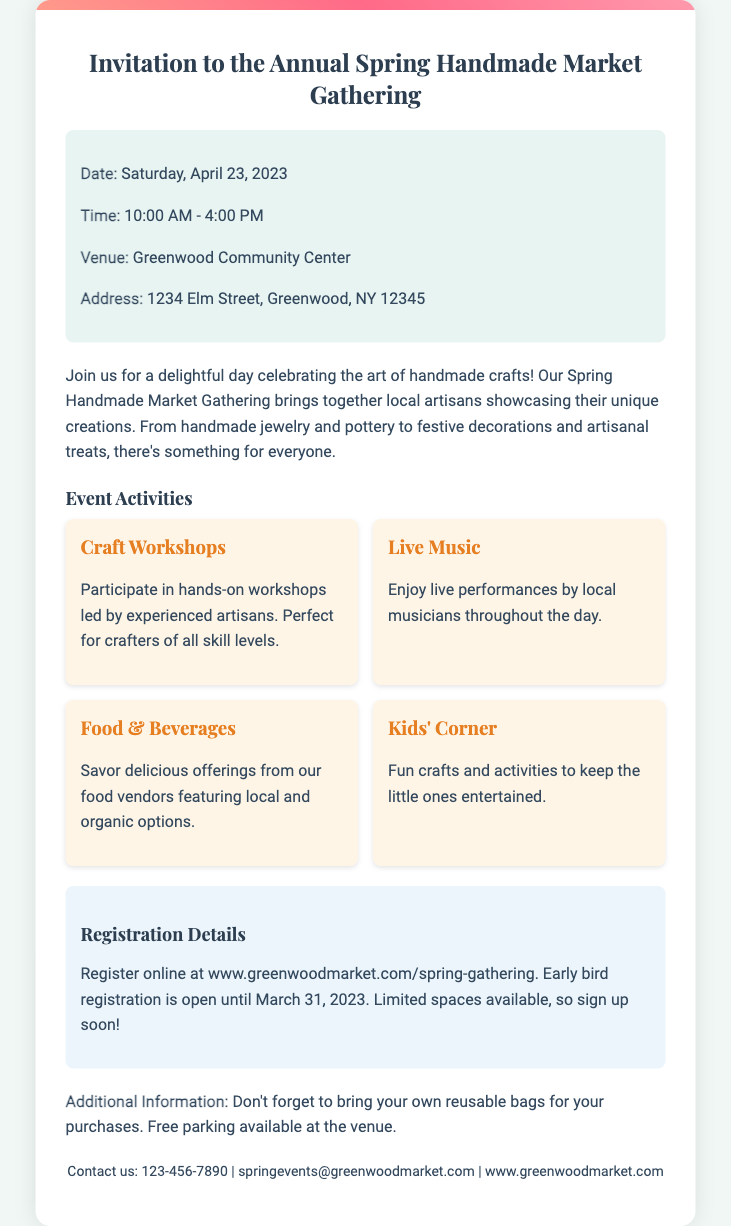What is the date of the event? The date of the event is specified clearly in the invitation as Saturday, April 23, 2023.
Answer: Saturday, April 23, 2023 What is the venue name? The invitation states the venue name as Greenwood Community Center.
Answer: Greenwood Community Center What time does the market start? The invitation lists the market start time as 10:00 AM.
Answer: 10:00 AM What activities are planned for the event? The document outlines several activities, including Craft Workshops, Live Music, Food & Beverages, and Kids' Corner.
Answer: Craft Workshops, Live Music, Food & Beverages, Kids' Corner Why should attendees register early? The registration mentions that early bird registration is open until March 31, 2023, and that spaces are limited, encouraging quick sign-ups.
Answer: Spaces are limited What should attendees bring for their purchases? Attendees are reminded to bring reusable bags for their purchases as indicated in the additional information section of the invitation.
Answer: Reusable bags How can participants register? The registration details include a website link where participants can register online for the event.
Answer: www.greenwoodmarket.com/spring-gathering What is provided at the venue for parking? The invitation states that free parking is available at the venue, providing convenience for attendees.
Answer: Free parking 